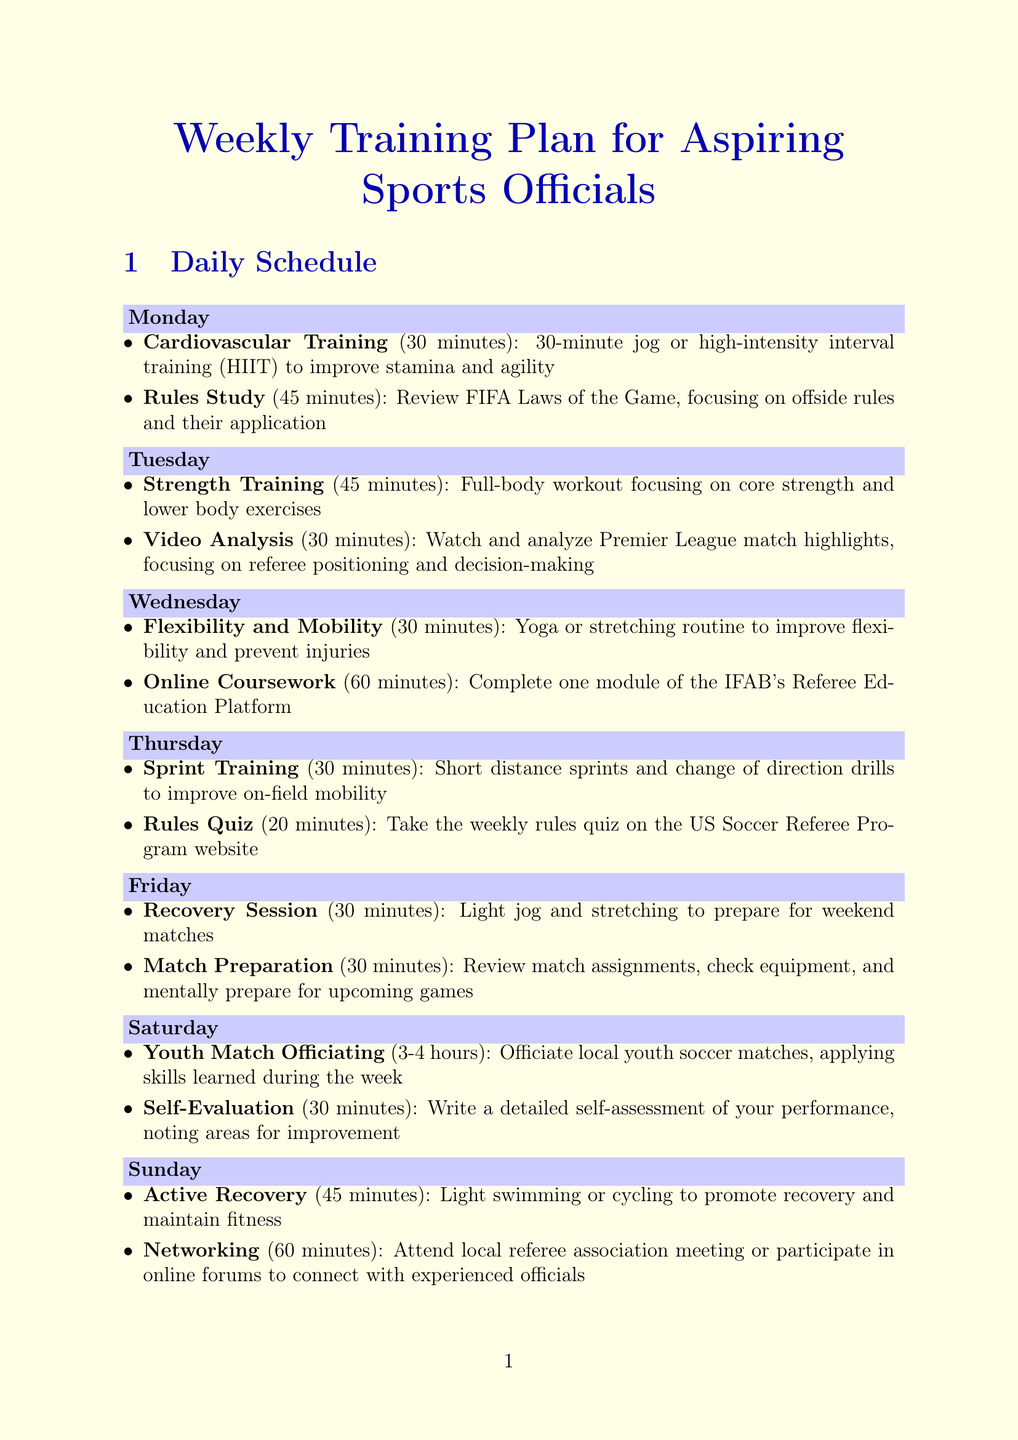What is the duration of the Recovery Session? The Recovery Session lasts for 30 minutes as stated in the Friday activities.
Answer: 30 minutes What activity is scheduled for Saturday? The Saturday activities include officiating local youth matches and self-evaluation.
Answer: Youth Match Officiating What is the focus of the Rules Study on Monday? The Rules Study on Monday focuses on the FIFA Laws of the Game, specifically the offside rules.
Answer: Offside rules How long is the Active Recovery session on Sunday? The Active Recovery session on Sunday lasts for 45 minutes, as described in the schedule.
Answer: 45 minutes What type of training is on Tuesday? Tuesday includes Strength Training and Video Analysis as its activities.
Answer: Strength Training Which platform offers online courses for aspiring referees? The US Soccer Learning Center provides an online platform with resources for referees as mentioned in the additional resources.
Answer: US Soccer Learning Center What is the purpose of the Self-Evaluation on Saturday? The Self-Evaluation is meant to allow officials to write a detailed self-assessment of their performance.
Answer: Performance assessment What is the recommended activity for flexibility on Wednesday? The Wednesday activity for flexibility is Yoga or stretching to improve flexibility and prevent injuries.
Answer: Yoga or stretching 